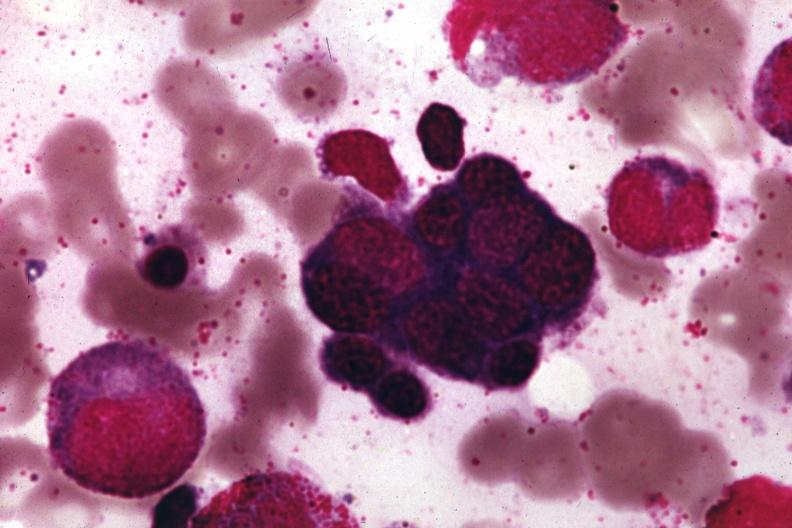s bone marrow present?
Answer the question using a single word or phrase. Yes 